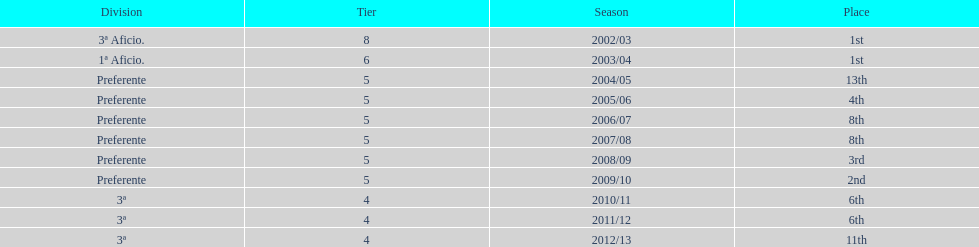Which division has the largest number of ranks? Preferente. 